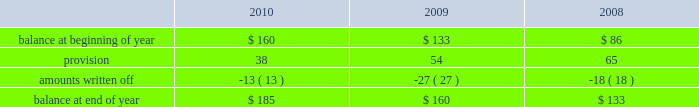Allowance for doubtful accounts is as follows: .
Discontinued operations during the fourth quarter of 2009 , schlumberger recorded a net $ 22 million charge related to the resolution of a customs assessment pertaining to its former offshore contract drilling business , as well as the resolution of certain contingencies associated with other previously disposed of businesses .
This amount is included in income ( loss ) from discontinued operations in the consolidated statement of income .
During the first quarter of 2008 , schlumberger recorded a gain of $ 38 million related to the resolution of a contingency associated with a previously disposed of business .
This gain is included in income ( loss ) from discon- tinued operations in the consolidated statement of income .
Part ii , item 8 .
What was the net change in the allowance in doubtful accounts in 2009? 
Rationale: the net change for the period is the increase plus the decrease
Computations: (54 + -27)
Answer: 27.0. 